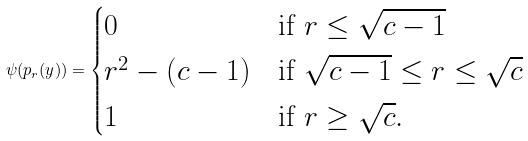<formula> <loc_0><loc_0><loc_500><loc_500>\psi ( p _ { r } ( y ) ) = \begin{cases} 0 & \text {if } r \leq \sqrt { c - 1 } \\ r ^ { 2 } - ( c - 1 ) & \text {if } \sqrt { c - 1 } \leq r \leq \sqrt { c } \\ 1 & \text {if } r \geq \sqrt { c } . \end{cases}</formula> 